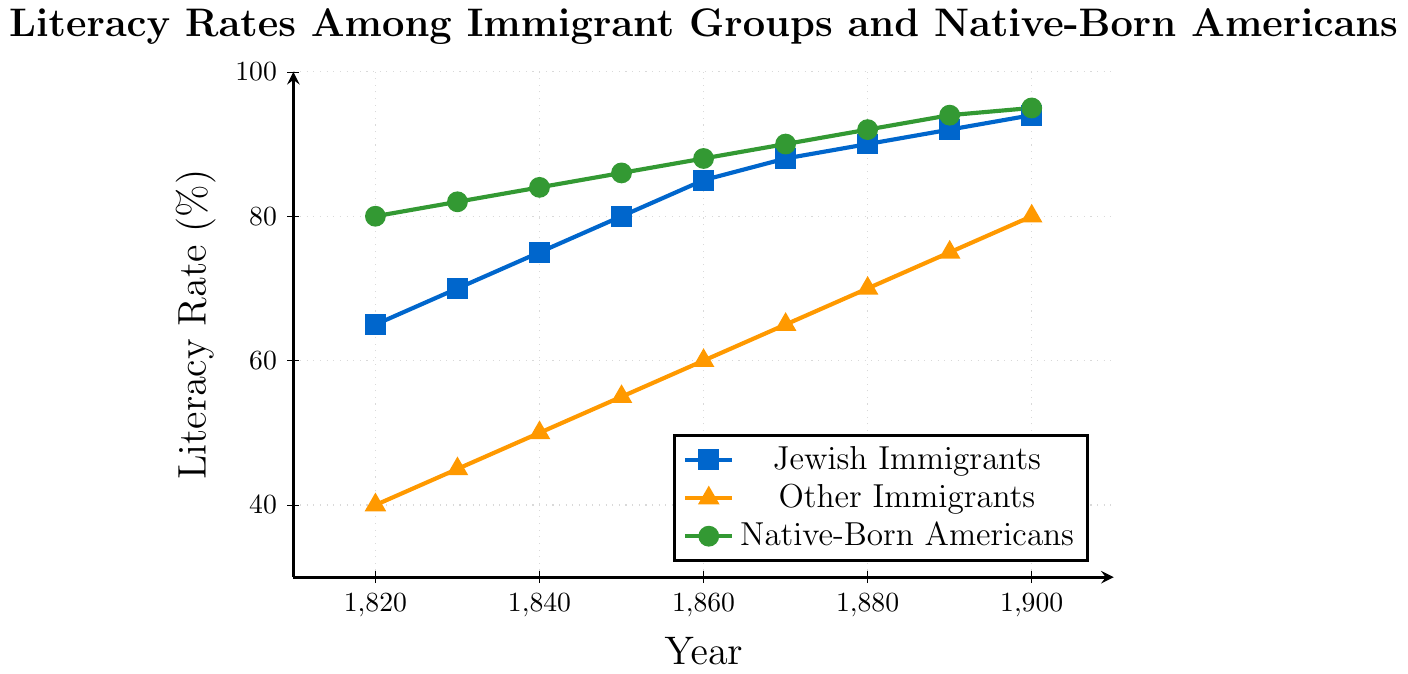Which year saw the highest literacy rate among Jewish immigrants? In the data, check the highest value for the Jewish Immigrant literacy rate. The year 1900 has the highest rate at 94%.
Answer: 1900 What is the difference in literacy rates between Jewish immigrants and other immigrants in 1860? Locate the values for Jewish immigrants and other immigrants in 1860. Jewish Immigrants have 85%, and Other Immigrants have 60%. The difference is 85 - 60 = 25%.
Answer: 25% How did the literacy rate of Native-Born Americans change from 1820 to 1900? Compare the values of Native-Born Americans in 1820 and 1900. In 1820, the rate is 80%, and in 1900, it is 95%. The change is 95 - 80 = 15%.
Answer: 15% In which decade did other immigrant literacy rates first reach 70%? Look through the data and find when other immigrants' rates hit 70% for the first time. In 1880, it is 70%.
Answer: 1880 By how much did the literacy rate of Jewish immigrants increase from 1820 to 1850? Review the literacy rates of Jewish immigrants in 1820 and 1850. The rates are 65% and 80% respectively. The increase is 80 - 65 = 15%.
Answer: 15% Which group had a greater increase in literacy rate from 1880 to 1900, Jewish immigrants or other immigrants? Calculate the increment for both Jewish and Other immigrants between 1880 and 1900. Jewish immigrants increased from 90% to 94% (4%), while other immigrants increased from 70% to 80% (10%).
Answer: Other immigrants What is the average literacy rate of native-born Americans over the recorded years? Add up all the literacy rates of native-born Americans and divide by the number of years. (80 + 82 + 84 + 86 + 88 + 90 + 92 + 94 + 95) / 9 = 87.89%.
Answer: 87.89% Compare the literacy rates of all three groups in 1840. Look at the values for Jewish immigrants, other immigrants, and Native-Born Americans in 1840. Jewish Immigrants: 75%, Other Immigrants: 50%, Native-Born Americans: 84%.
Answer: Jewish Immigrants: 75%, Other Immigrants: 50%, Native-Born Americans: 84% In which year did Jewish immigrants' literacy rate equal the native-born Americans' literacy rate of 1820? Check when the literacy rate of Jewish immigrants reached 80%. It equals the 1820 rate of Native-Born Americans in 1850.
Answer: 1850 What color represents other immigrants in the plot? Observe the color used for other immigrants. The plot marks other immigrants with an orange line.
Answer: orange 